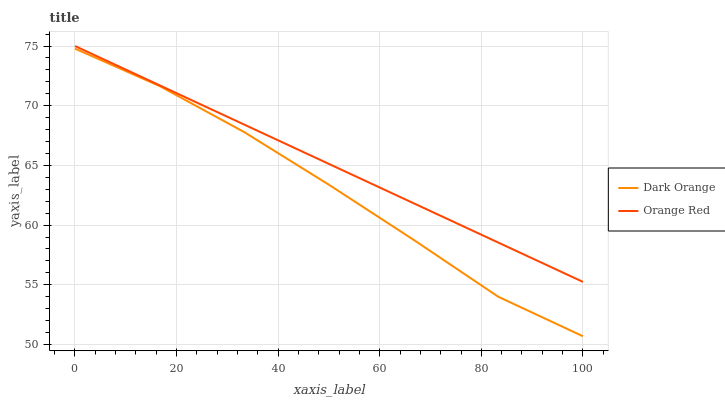Does Dark Orange have the minimum area under the curve?
Answer yes or no. Yes. Does Orange Red have the maximum area under the curve?
Answer yes or no. Yes. Does Orange Red have the minimum area under the curve?
Answer yes or no. No. Is Orange Red the smoothest?
Answer yes or no. Yes. Is Dark Orange the roughest?
Answer yes or no. Yes. Is Orange Red the roughest?
Answer yes or no. No. Does Dark Orange have the lowest value?
Answer yes or no. Yes. Does Orange Red have the lowest value?
Answer yes or no. No. Does Orange Red have the highest value?
Answer yes or no. Yes. Is Dark Orange less than Orange Red?
Answer yes or no. Yes. Is Orange Red greater than Dark Orange?
Answer yes or no. Yes. Does Dark Orange intersect Orange Red?
Answer yes or no. No. 